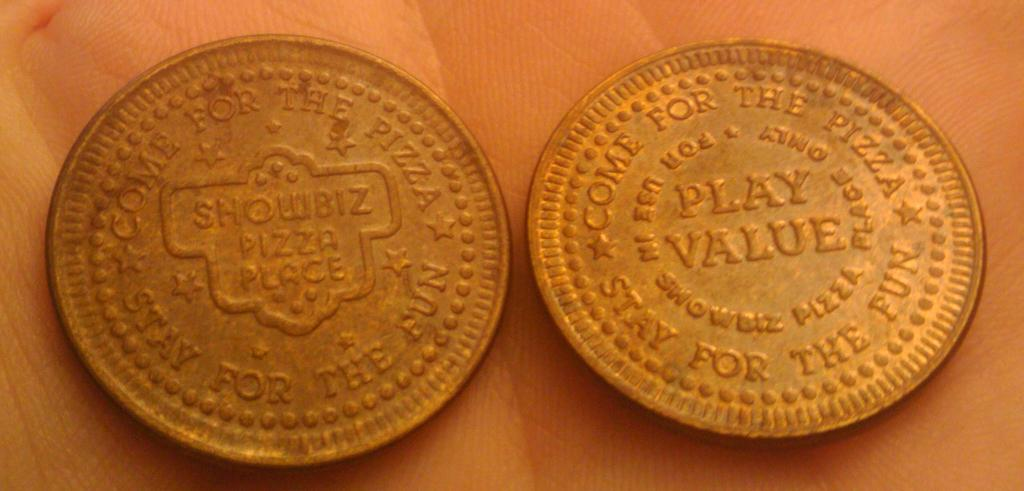Provide a one-sentence caption for the provided image. Two gold coin with engraving that says Showbiz Pizza Place. 